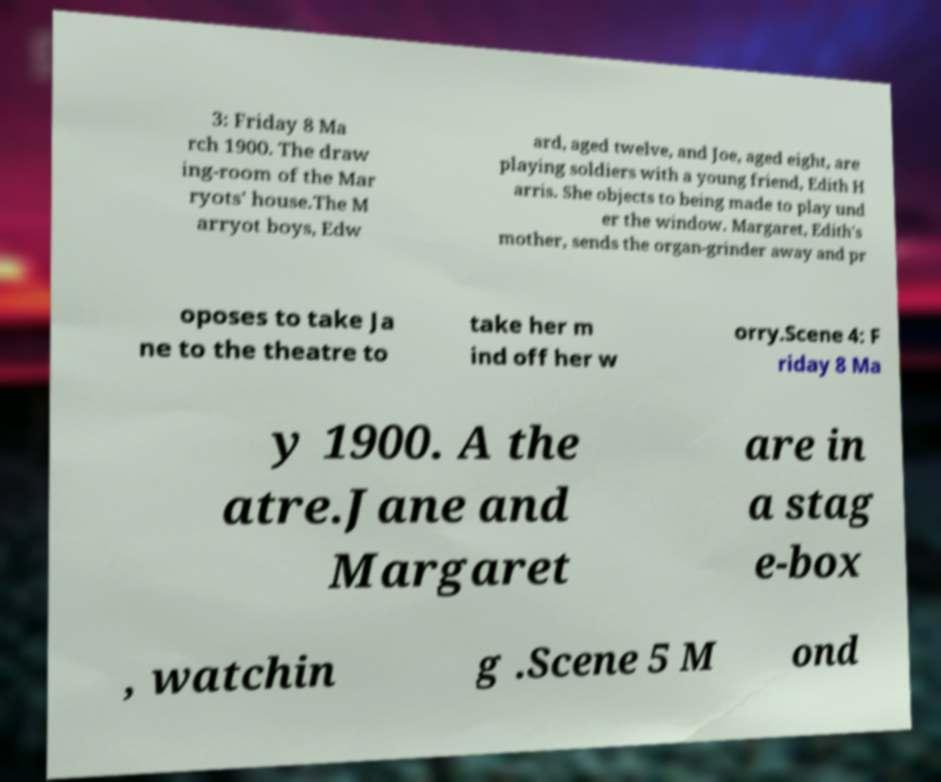What messages or text are displayed in this image? I need them in a readable, typed format. 3: Friday 8 Ma rch 1900. The draw ing-room of the Mar ryots' house.The M arryot boys, Edw ard, aged twelve, and Joe, aged eight, are playing soldiers with a young friend, Edith H arris. She objects to being made to play und er the window. Margaret, Edith's mother, sends the organ-grinder away and pr oposes to take Ja ne to the theatre to take her m ind off her w orry.Scene 4: F riday 8 Ma y 1900. A the atre.Jane and Margaret are in a stag e-box , watchin g .Scene 5 M ond 